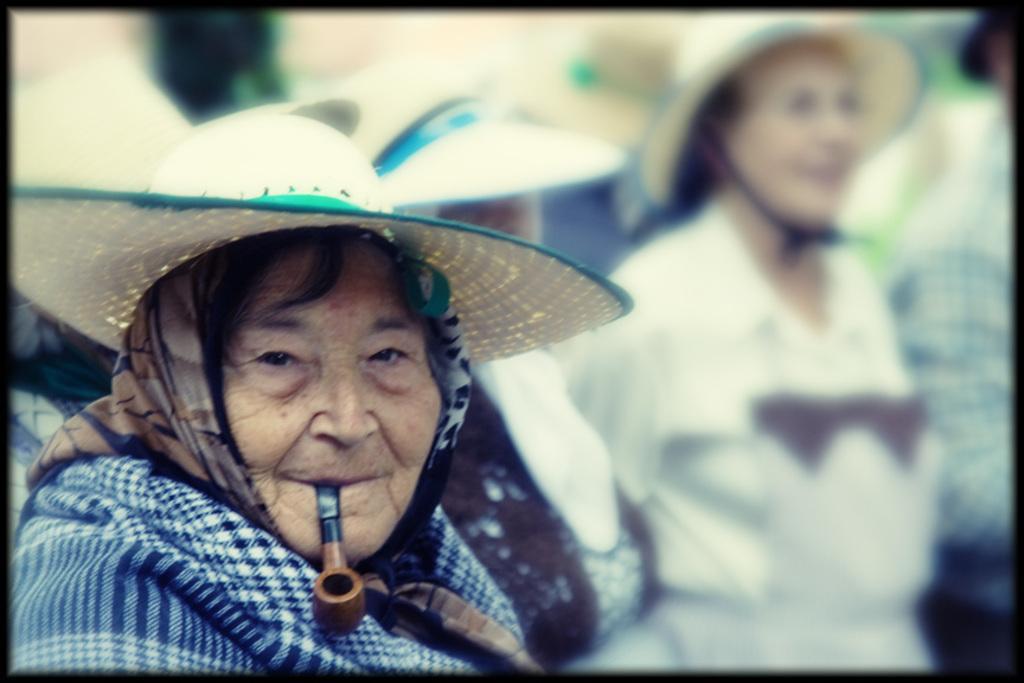Please provide a concise description of this image. In this image I can see a person wearing cream colored hat and blue colored cloth and I can see a cigar which is black and brown in color in her mouth. In the background I can see few other persons wearing hats are standing. 